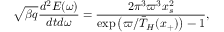<formula> <loc_0><loc_0><loc_500><loc_500>\sqrt { \beta q } \frac { d ^ { 2 } E ( \omega ) } { d t d \omega } = \frac { 2 \pi ^ { 3 } \varpi ^ { 3 } x _ { s } ^ { 2 } } { \exp \left ( \varpi / \bar { T } _ { H } ( x _ { + } ) \right ) - 1 } ,</formula> 